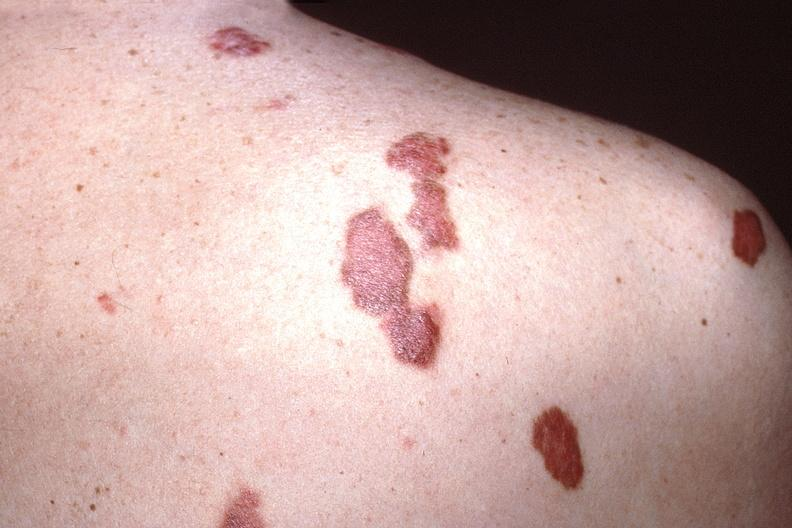does there show skin, kaposis 's sarcoma?
Answer the question using a single word or phrase. No 